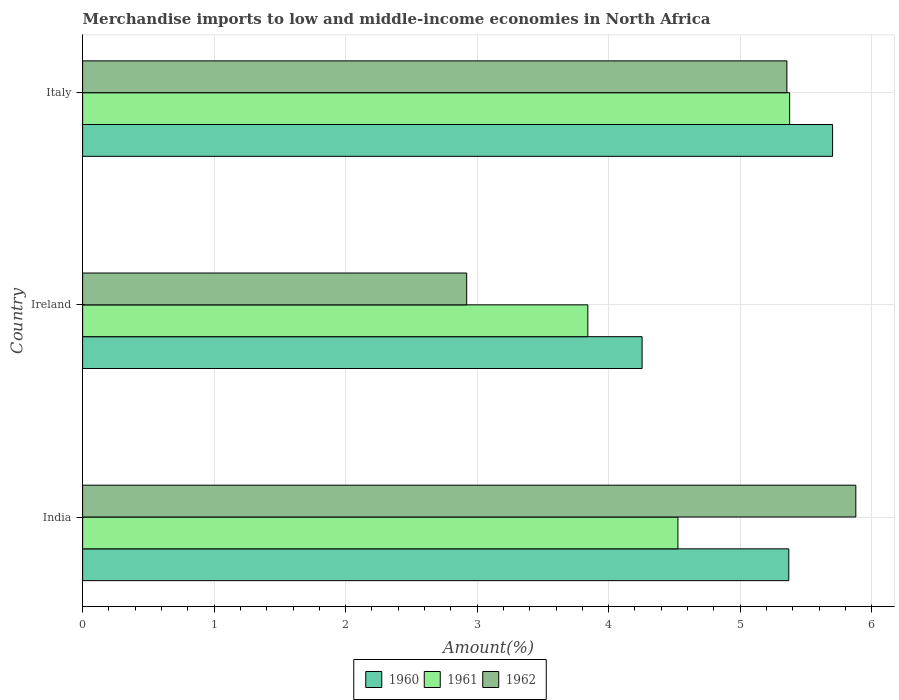Are the number of bars per tick equal to the number of legend labels?
Your response must be concise. Yes. Are the number of bars on each tick of the Y-axis equal?
Your answer should be very brief. Yes. What is the label of the 2nd group of bars from the top?
Make the answer very short. Ireland. What is the percentage of amount earned from merchandise imports in 1961 in Italy?
Offer a terse response. 5.38. Across all countries, what is the maximum percentage of amount earned from merchandise imports in 1960?
Offer a terse response. 5.7. Across all countries, what is the minimum percentage of amount earned from merchandise imports in 1962?
Ensure brevity in your answer.  2.92. In which country was the percentage of amount earned from merchandise imports in 1960 minimum?
Keep it short and to the point. Ireland. What is the total percentage of amount earned from merchandise imports in 1961 in the graph?
Your answer should be compact. 13.75. What is the difference between the percentage of amount earned from merchandise imports in 1960 in India and that in Ireland?
Offer a terse response. 1.12. What is the difference between the percentage of amount earned from merchandise imports in 1961 in Italy and the percentage of amount earned from merchandise imports in 1960 in Ireland?
Provide a succinct answer. 1.12. What is the average percentage of amount earned from merchandise imports in 1960 per country?
Your response must be concise. 5.11. What is the difference between the percentage of amount earned from merchandise imports in 1962 and percentage of amount earned from merchandise imports in 1960 in Ireland?
Give a very brief answer. -1.33. What is the ratio of the percentage of amount earned from merchandise imports in 1960 in India to that in Ireland?
Give a very brief answer. 1.26. What is the difference between the highest and the second highest percentage of amount earned from merchandise imports in 1962?
Give a very brief answer. 0.52. What is the difference between the highest and the lowest percentage of amount earned from merchandise imports in 1962?
Provide a short and direct response. 2.96. In how many countries, is the percentage of amount earned from merchandise imports in 1962 greater than the average percentage of amount earned from merchandise imports in 1962 taken over all countries?
Your response must be concise. 2. What does the 2nd bar from the top in Italy represents?
Your answer should be very brief. 1961. What does the 1st bar from the bottom in Ireland represents?
Your answer should be very brief. 1960. Are all the bars in the graph horizontal?
Give a very brief answer. Yes. How many countries are there in the graph?
Make the answer very short. 3. What is the difference between two consecutive major ticks on the X-axis?
Ensure brevity in your answer.  1. Are the values on the major ticks of X-axis written in scientific E-notation?
Your response must be concise. No. Does the graph contain grids?
Your answer should be compact. Yes. Where does the legend appear in the graph?
Your answer should be very brief. Bottom center. How many legend labels are there?
Keep it short and to the point. 3. What is the title of the graph?
Ensure brevity in your answer.  Merchandise imports to low and middle-income economies in North Africa. What is the label or title of the X-axis?
Your response must be concise. Amount(%). What is the Amount(%) of 1960 in India?
Ensure brevity in your answer.  5.37. What is the Amount(%) in 1961 in India?
Provide a short and direct response. 4.53. What is the Amount(%) in 1962 in India?
Ensure brevity in your answer.  5.88. What is the Amount(%) of 1960 in Ireland?
Offer a very short reply. 4.25. What is the Amount(%) of 1961 in Ireland?
Offer a very short reply. 3.84. What is the Amount(%) in 1962 in Ireland?
Keep it short and to the point. 2.92. What is the Amount(%) of 1960 in Italy?
Your response must be concise. 5.7. What is the Amount(%) of 1961 in Italy?
Keep it short and to the point. 5.38. What is the Amount(%) in 1962 in Italy?
Provide a succinct answer. 5.36. Across all countries, what is the maximum Amount(%) in 1960?
Offer a very short reply. 5.7. Across all countries, what is the maximum Amount(%) in 1961?
Your response must be concise. 5.38. Across all countries, what is the maximum Amount(%) of 1962?
Your answer should be very brief. 5.88. Across all countries, what is the minimum Amount(%) in 1960?
Ensure brevity in your answer.  4.25. Across all countries, what is the minimum Amount(%) in 1961?
Keep it short and to the point. 3.84. Across all countries, what is the minimum Amount(%) of 1962?
Keep it short and to the point. 2.92. What is the total Amount(%) in 1960 in the graph?
Offer a very short reply. 15.33. What is the total Amount(%) in 1961 in the graph?
Offer a very short reply. 13.75. What is the total Amount(%) of 1962 in the graph?
Your response must be concise. 14.16. What is the difference between the Amount(%) in 1960 in India and that in Ireland?
Offer a very short reply. 1.12. What is the difference between the Amount(%) of 1961 in India and that in Ireland?
Give a very brief answer. 0.69. What is the difference between the Amount(%) of 1962 in India and that in Ireland?
Ensure brevity in your answer.  2.96. What is the difference between the Amount(%) of 1960 in India and that in Italy?
Your answer should be very brief. -0.33. What is the difference between the Amount(%) in 1961 in India and that in Italy?
Provide a short and direct response. -0.85. What is the difference between the Amount(%) of 1962 in India and that in Italy?
Your response must be concise. 0.52. What is the difference between the Amount(%) in 1960 in Ireland and that in Italy?
Your answer should be very brief. -1.45. What is the difference between the Amount(%) in 1961 in Ireland and that in Italy?
Your answer should be very brief. -1.53. What is the difference between the Amount(%) of 1962 in Ireland and that in Italy?
Keep it short and to the point. -2.44. What is the difference between the Amount(%) of 1960 in India and the Amount(%) of 1961 in Ireland?
Offer a terse response. 1.53. What is the difference between the Amount(%) of 1960 in India and the Amount(%) of 1962 in Ireland?
Your response must be concise. 2.45. What is the difference between the Amount(%) of 1961 in India and the Amount(%) of 1962 in Ireland?
Provide a succinct answer. 1.61. What is the difference between the Amount(%) in 1960 in India and the Amount(%) in 1961 in Italy?
Your response must be concise. -0.01. What is the difference between the Amount(%) in 1960 in India and the Amount(%) in 1962 in Italy?
Your response must be concise. 0.01. What is the difference between the Amount(%) in 1961 in India and the Amount(%) in 1962 in Italy?
Offer a terse response. -0.83. What is the difference between the Amount(%) in 1960 in Ireland and the Amount(%) in 1961 in Italy?
Provide a short and direct response. -1.12. What is the difference between the Amount(%) in 1960 in Ireland and the Amount(%) in 1962 in Italy?
Ensure brevity in your answer.  -1.1. What is the difference between the Amount(%) in 1961 in Ireland and the Amount(%) in 1962 in Italy?
Offer a very short reply. -1.51. What is the average Amount(%) in 1960 per country?
Offer a terse response. 5.11. What is the average Amount(%) in 1961 per country?
Provide a short and direct response. 4.58. What is the average Amount(%) in 1962 per country?
Offer a terse response. 4.72. What is the difference between the Amount(%) of 1960 and Amount(%) of 1961 in India?
Ensure brevity in your answer.  0.84. What is the difference between the Amount(%) of 1960 and Amount(%) of 1962 in India?
Provide a succinct answer. -0.51. What is the difference between the Amount(%) in 1961 and Amount(%) in 1962 in India?
Provide a succinct answer. -1.35. What is the difference between the Amount(%) of 1960 and Amount(%) of 1961 in Ireland?
Your answer should be very brief. 0.41. What is the difference between the Amount(%) of 1960 and Amount(%) of 1962 in Ireland?
Your response must be concise. 1.33. What is the difference between the Amount(%) in 1961 and Amount(%) in 1962 in Ireland?
Offer a terse response. 0.92. What is the difference between the Amount(%) of 1960 and Amount(%) of 1961 in Italy?
Ensure brevity in your answer.  0.33. What is the difference between the Amount(%) in 1960 and Amount(%) in 1962 in Italy?
Ensure brevity in your answer.  0.35. What is the difference between the Amount(%) in 1961 and Amount(%) in 1962 in Italy?
Ensure brevity in your answer.  0.02. What is the ratio of the Amount(%) of 1960 in India to that in Ireland?
Ensure brevity in your answer.  1.26. What is the ratio of the Amount(%) in 1961 in India to that in Ireland?
Give a very brief answer. 1.18. What is the ratio of the Amount(%) of 1962 in India to that in Ireland?
Offer a terse response. 2.01. What is the ratio of the Amount(%) of 1960 in India to that in Italy?
Keep it short and to the point. 0.94. What is the ratio of the Amount(%) in 1961 in India to that in Italy?
Give a very brief answer. 0.84. What is the ratio of the Amount(%) of 1962 in India to that in Italy?
Keep it short and to the point. 1.1. What is the ratio of the Amount(%) in 1960 in Ireland to that in Italy?
Give a very brief answer. 0.75. What is the ratio of the Amount(%) in 1961 in Ireland to that in Italy?
Your response must be concise. 0.71. What is the ratio of the Amount(%) of 1962 in Ireland to that in Italy?
Offer a terse response. 0.55. What is the difference between the highest and the second highest Amount(%) in 1960?
Your answer should be very brief. 0.33. What is the difference between the highest and the second highest Amount(%) of 1961?
Provide a succinct answer. 0.85. What is the difference between the highest and the second highest Amount(%) of 1962?
Your response must be concise. 0.52. What is the difference between the highest and the lowest Amount(%) of 1960?
Offer a terse response. 1.45. What is the difference between the highest and the lowest Amount(%) in 1961?
Make the answer very short. 1.53. What is the difference between the highest and the lowest Amount(%) in 1962?
Provide a short and direct response. 2.96. 